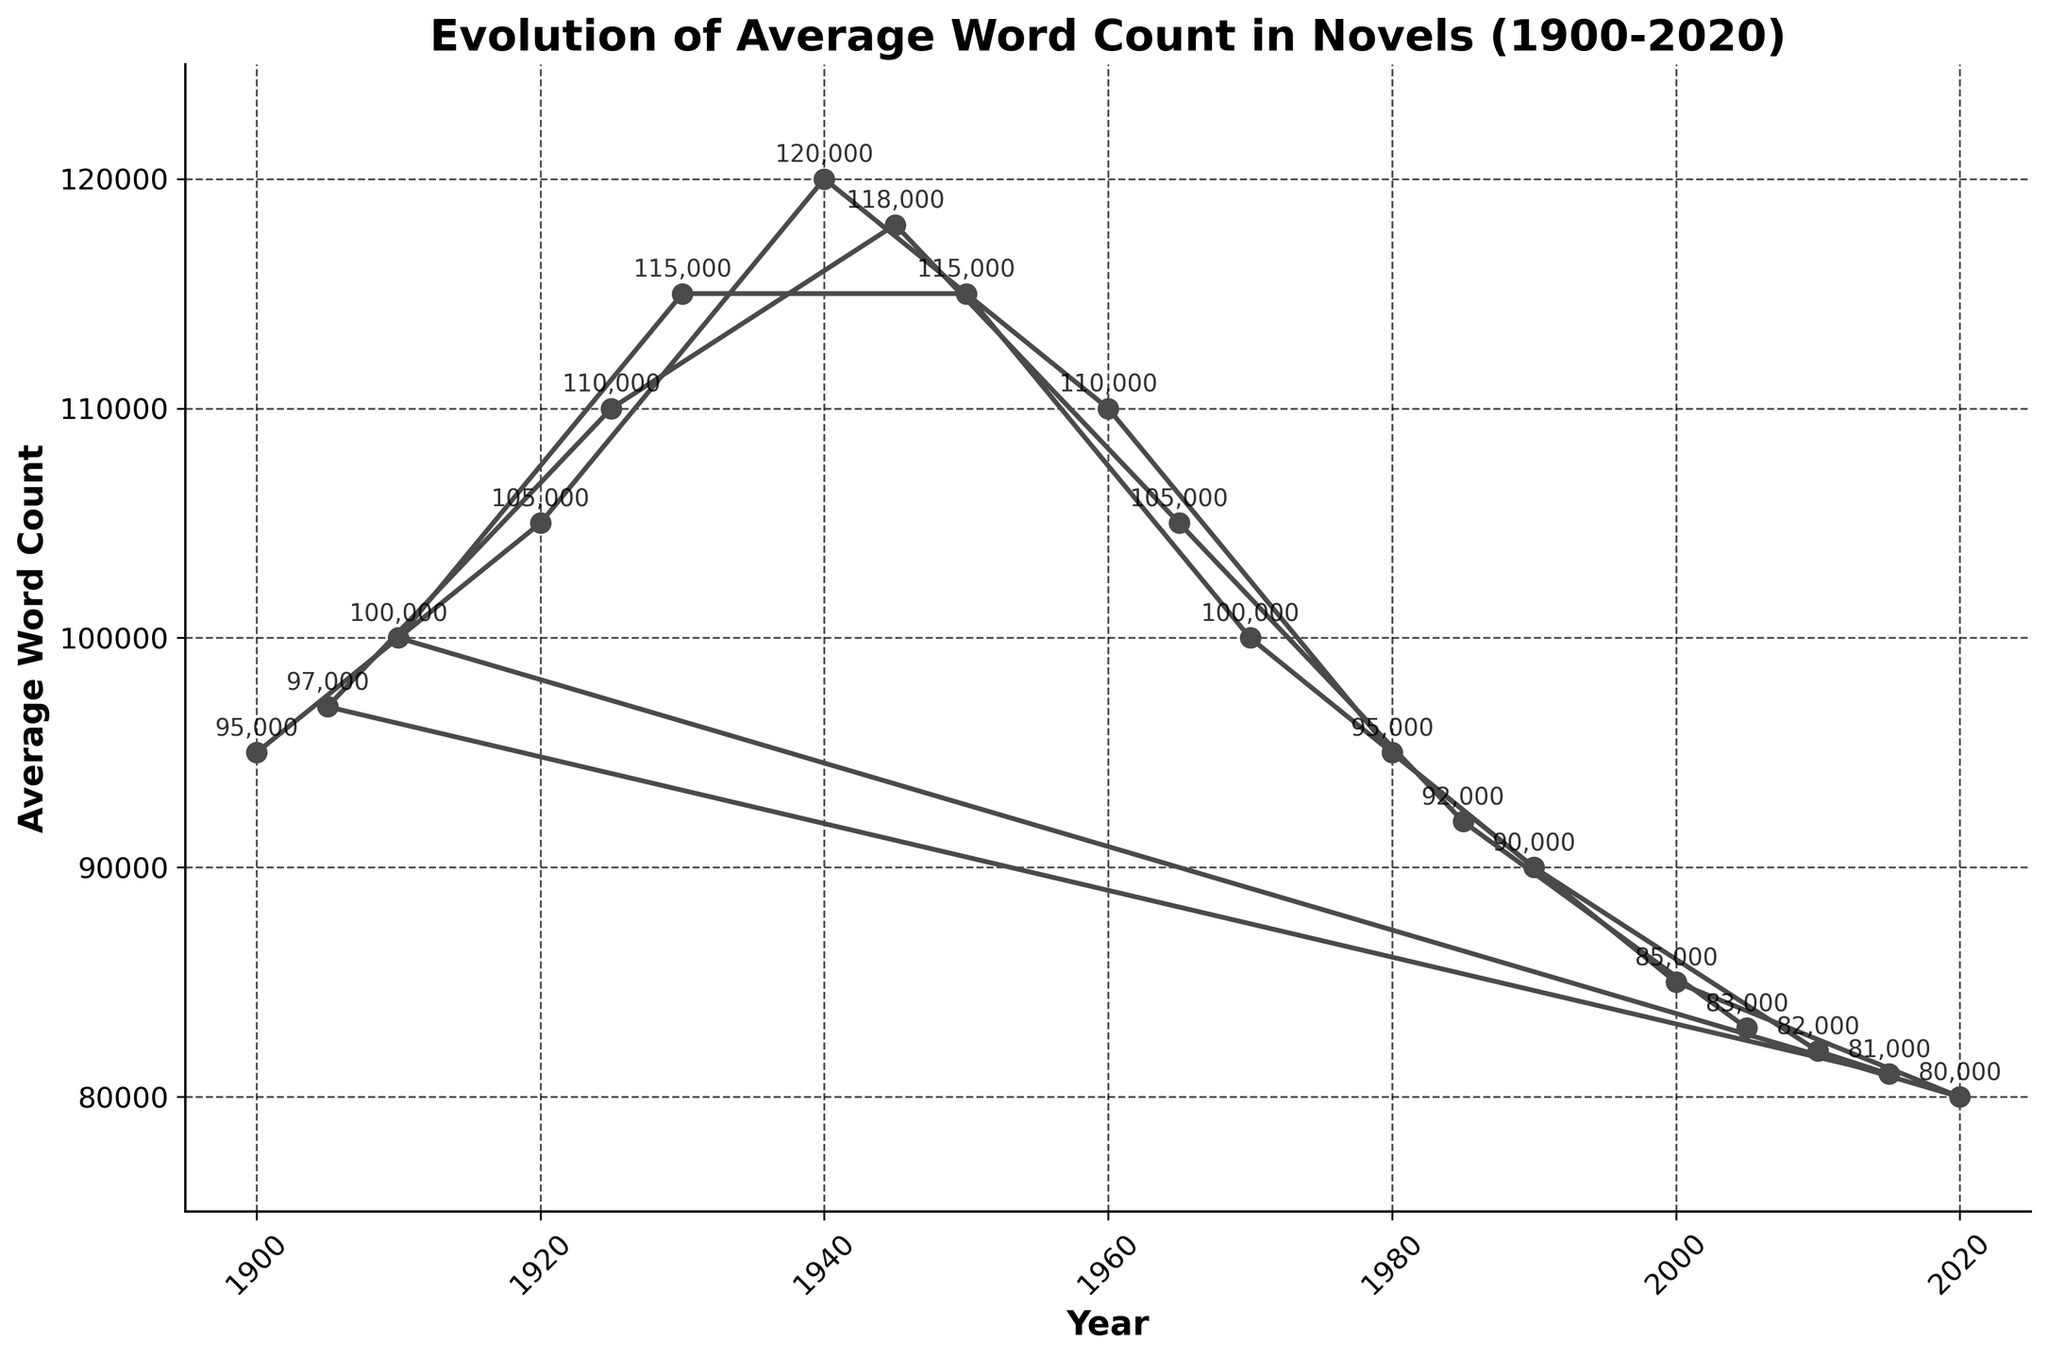What is the general trend of the average word count in novels from 1900 to 2020? From 1900 to around 1960, the average word count generally increased. After a peak around 1940 and 1950, the word count shows a fluctuating decline, reaching its lowest value by 2020.
Answer: Decreasing trend Between which two adjacent decades was the largest drop in word count observed? Look at the differences between adjacent points in the plot; the largest drop appears between 1940-1960 (120,000 to 110,000) or between 1990-2000 (90,000 to 85,000). For the largest, observe the point where the change is most significant.
Answer: 1990-2000 What was the average word count in novels around 1940? Locate the value corresponding to the year 1940 in the plot.
Answer: 120,000 What is the difference in average word count between novels in 2000 and 2020? Subtract the value in 2020 from the value in 2000 (85,000 - 80,000).
Answer: 5,000 In which time period did the average word count exceed 115,000? Look for values that are above 115,000 and check corresponding years: 1940 and 1950.
Answer: Around 1940-1950 How does the average word count in 1920 compare to that in 1925? Locate the values for these years and compare them, noting which is higher or lower.
Answer: 1920 is lower than 1925 What is the average word count difference between 1980 and 2000? Subtract the value of 2000 from 1980 (95,000 - 85,000).
Answer: 10,000 Which years between 1900 and 1925 show an upward trend in word count? Identify the general upward movement in the plot within these years; years like 1905, 1910, 1920, and 1925 show rising trends.
Answer: 1900-1925 How many years had an average word count above 100,000? Count the number of data points in the plot where the word count exceeds 100,000.
Answer: 8 years Compare the word count trends in novels from 1900-1940 with 1960-2000. From 1900-1940, the trend generally increases with minor fluctuations. In contrast, 1960-2000 shows an overall decline with some rises and falls.
Answer: 1900-1940 rising, 1960-2000 declining 